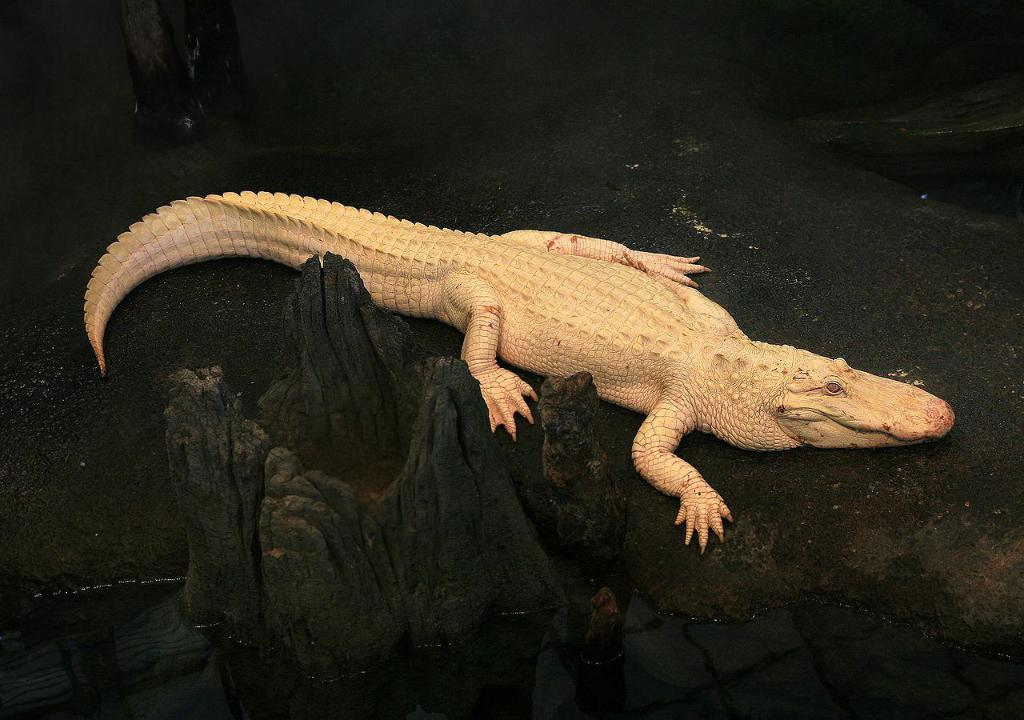What animal is present on the ground in the image? There is a crocodile on the ground in the image. What can be seen near the crocodile in the image? There is a black color tree trunk in the image. What natural element is visible in the image? Water is visible in the image. What type of advertisement can be seen on the crocodile's back in the image? There is no advertisement present on the crocodile's back in the image. 